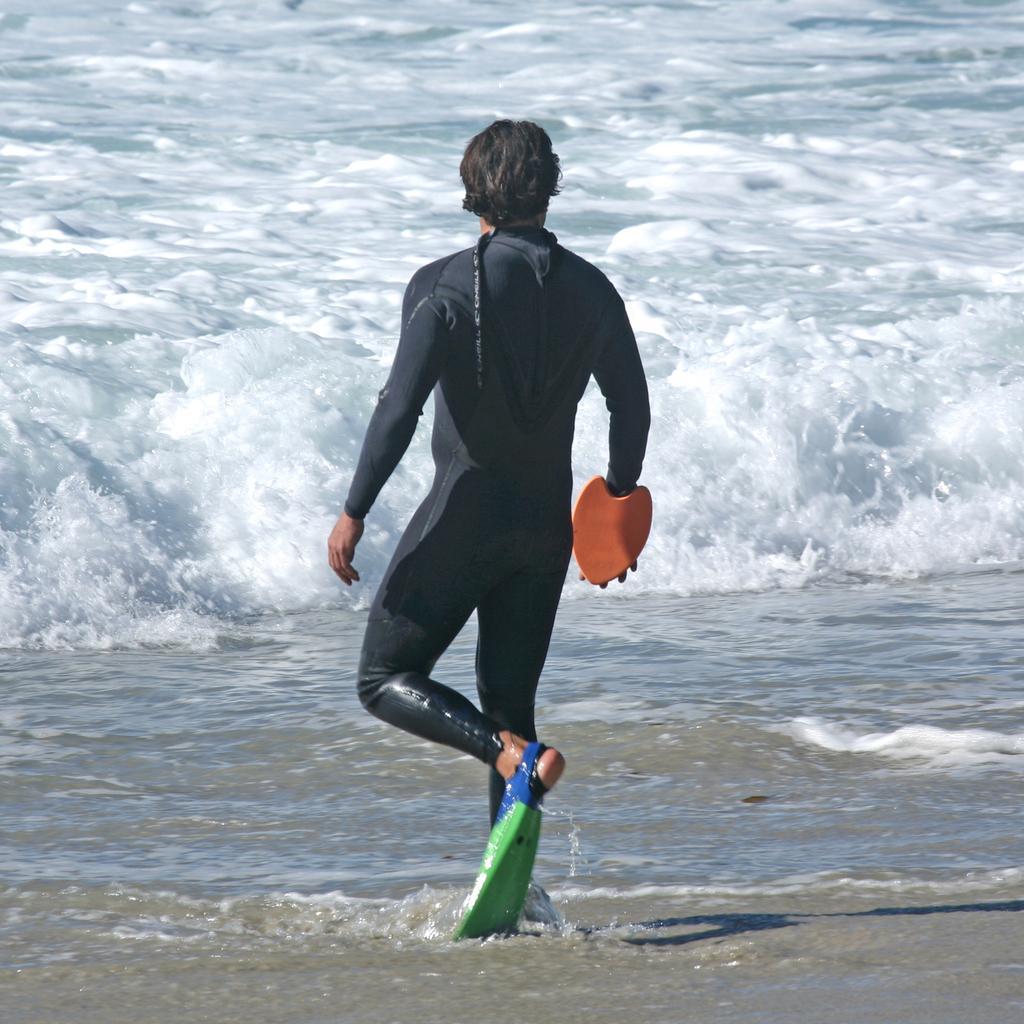Describe this image in one or two sentences. This picture shows a man walking into the water and he wore a black color dress. 